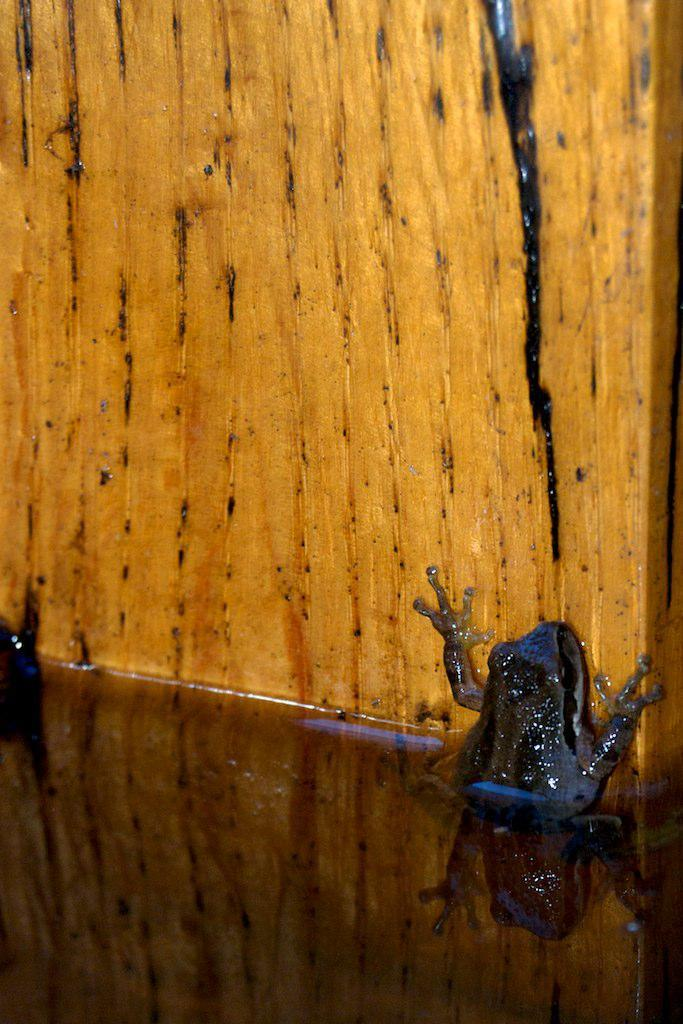What material is the board in the image made of? The wooden board in the image is made of wood. What is on top of the wooden board? There is a frog on the wooden board. What type of gold ornament is hanging from the middle of the wooden board? There is no gold ornament present on the wooden board in the image. 